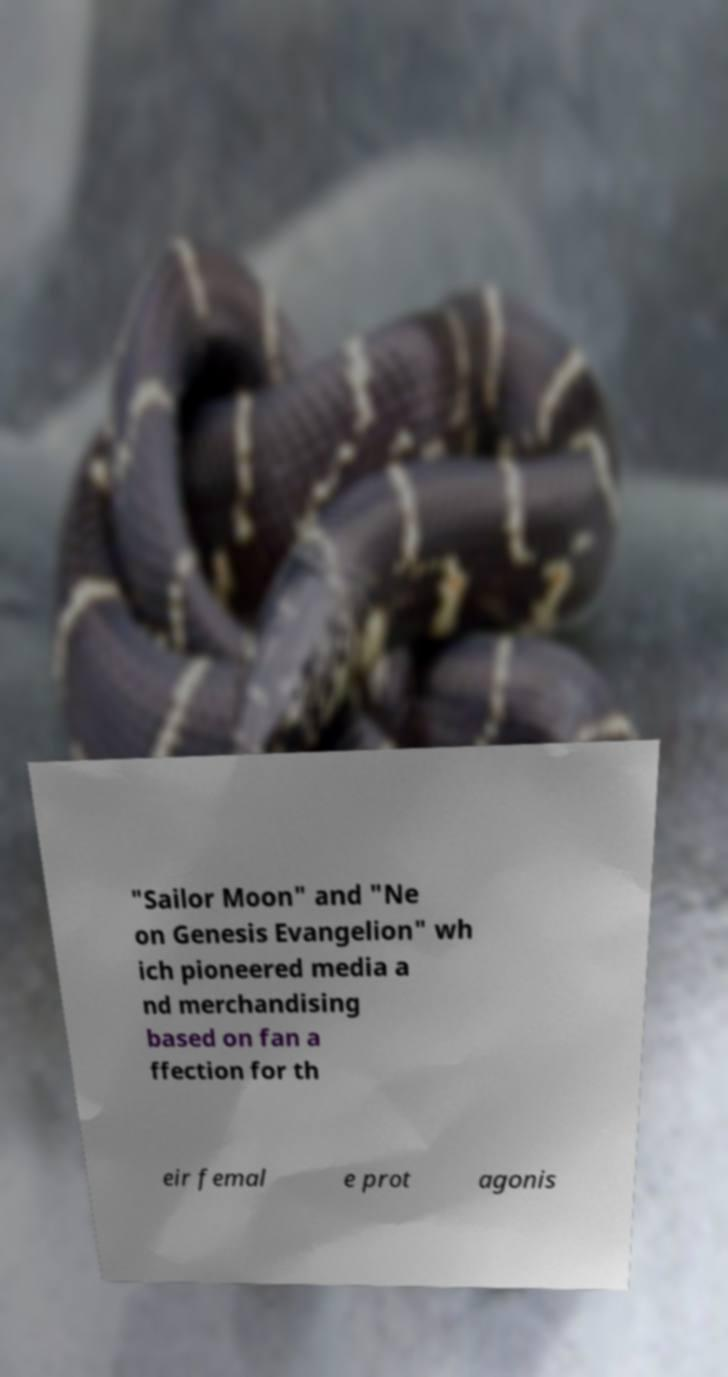I need the written content from this picture converted into text. Can you do that? "Sailor Moon" and "Ne on Genesis Evangelion" wh ich pioneered media a nd merchandising based on fan a ffection for th eir femal e prot agonis 